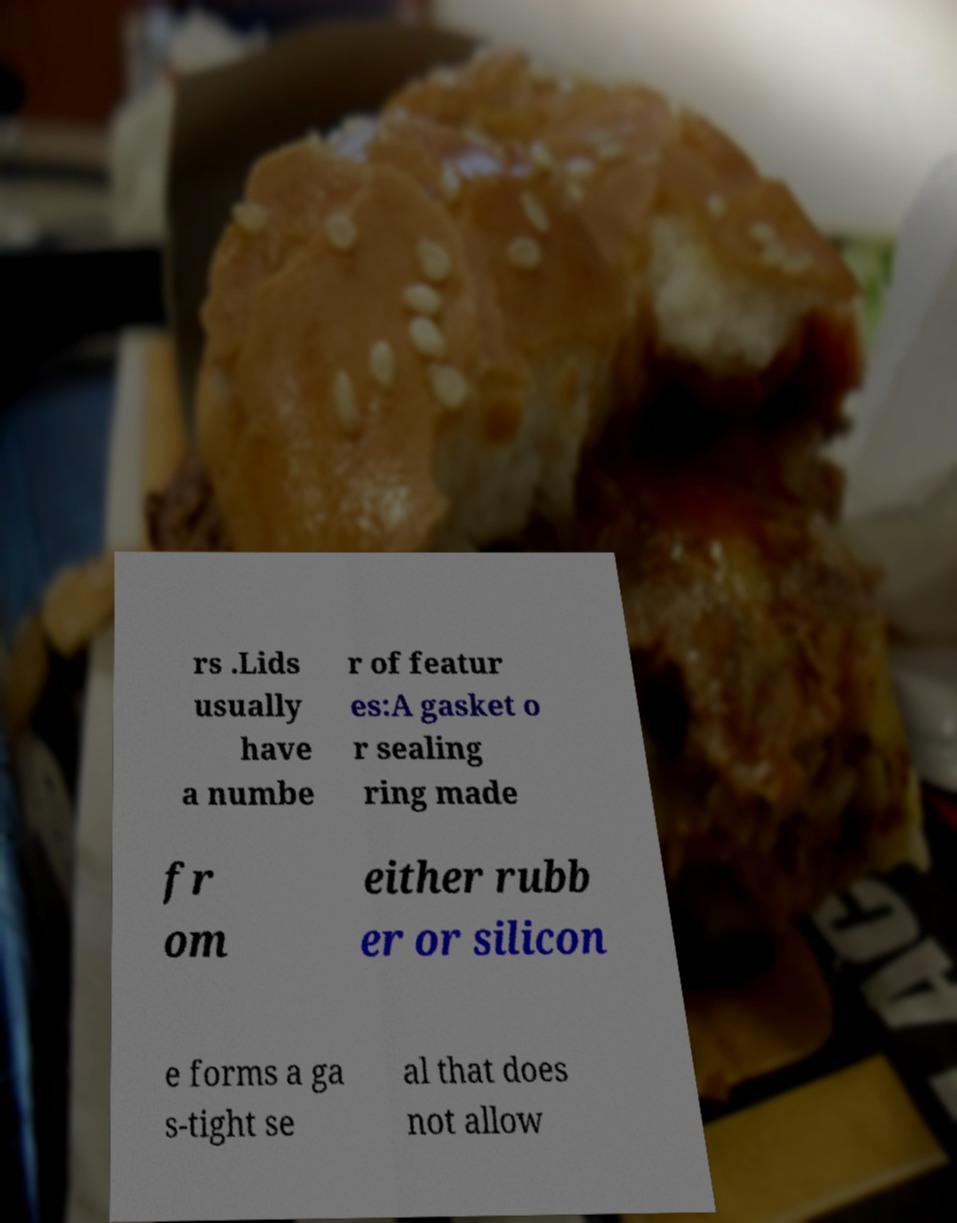Could you extract and type out the text from this image? rs .Lids usually have a numbe r of featur es:A gasket o r sealing ring made fr om either rubb er or silicon e forms a ga s-tight se al that does not allow 